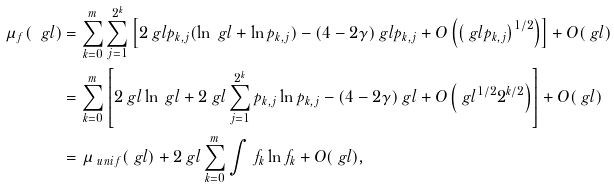<formula> <loc_0><loc_0><loc_500><loc_500>\mu _ { f } ( \ g l ) & = \sum _ { k = 0 } ^ { m } \sum _ { j = 1 } ^ { 2 ^ { k } } \left [ 2 \ g l p _ { k , j } ( \ln \ g l + \ln p _ { k , j } ) - ( 4 - 2 \gamma ) \ g l p _ { k , j } + O \left ( \left ( \ g l p _ { k , j } \right ) ^ { 1 / 2 } \right ) \right ] + O ( \ g l ) \\ & = \sum _ { k = 0 } ^ { m } \left [ 2 \ g l \ln \ g l + 2 \ g l \sum _ { j = 1 } ^ { 2 ^ { k } } p _ { k , j } \ln p _ { k , j } - ( 4 - 2 \gamma ) \ g l + O \left ( \ g l ^ { 1 / 2 } 2 ^ { k / 2 } \right ) \right ] + O ( \ g l ) \\ & = \mu _ { \ u n i f } ( \ g l ) + 2 \ g l \sum _ { k = 0 } ^ { m } \int \, f _ { k } \ln f _ { k } + O ( \ g l ) ,</formula> 